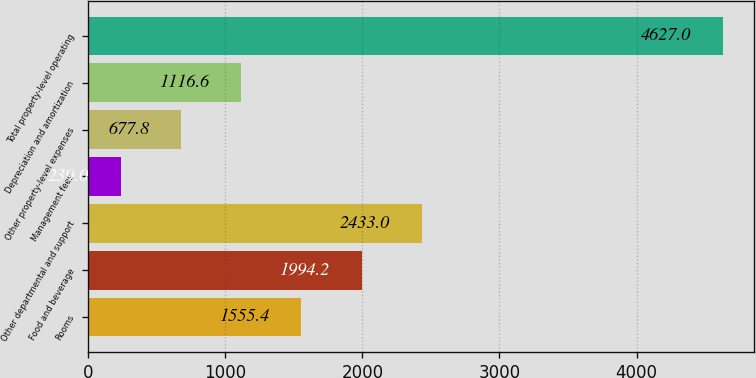<chart> <loc_0><loc_0><loc_500><loc_500><bar_chart><fcel>Rooms<fcel>Food and beverage<fcel>Other departmental and support<fcel>Management fees<fcel>Other property-level expenses<fcel>Depreciation and amortization<fcel>Total property-level operating<nl><fcel>1555.4<fcel>1994.2<fcel>2433<fcel>239<fcel>677.8<fcel>1116.6<fcel>4627<nl></chart> 